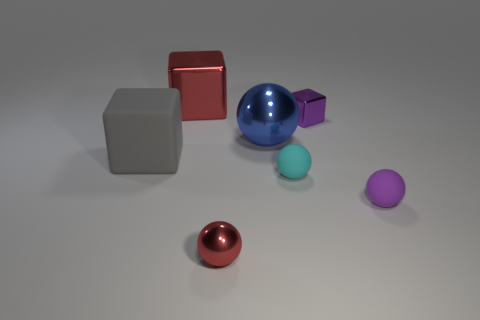Subtract all large blocks. How many blocks are left? 1 Add 3 purple matte balls. How many objects exist? 10 Subtract all purple cubes. How many cubes are left? 2 Subtract 1 cubes. How many cubes are left? 2 Add 2 large gray objects. How many large gray objects are left? 3 Add 1 brown shiny blocks. How many brown shiny blocks exist? 1 Subtract 0 gray cylinders. How many objects are left? 7 Subtract all spheres. How many objects are left? 3 Subtract all cyan blocks. Subtract all cyan cylinders. How many blocks are left? 3 Subtract all purple cubes. How many cyan balls are left? 1 